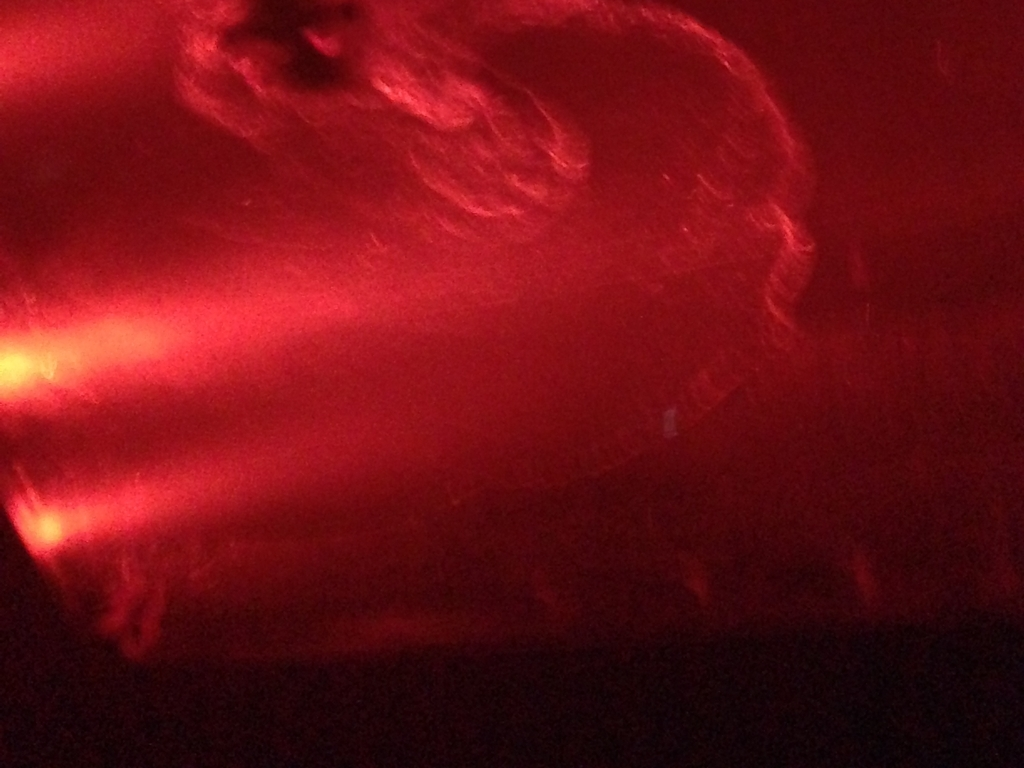Explore the quality factors of the image and offer an evaluation based on your insights. The image quality is considerably poor, primarily due to significant blurring and an overwhelming red hue that obscures any detailed viewing. The specific cause of the blurriness might be a low camera resolution, movement during the capture, or focus issues, while the red tone could result from lighting conditions or camera settings during the shot. Furthermore, the image exhibits a low dynamic range and saturation, possibly resulting from suboptimal exposure settings. Overall, these factors contribute to an image that is challenging to interpret and lacks visual clarity and detail. 